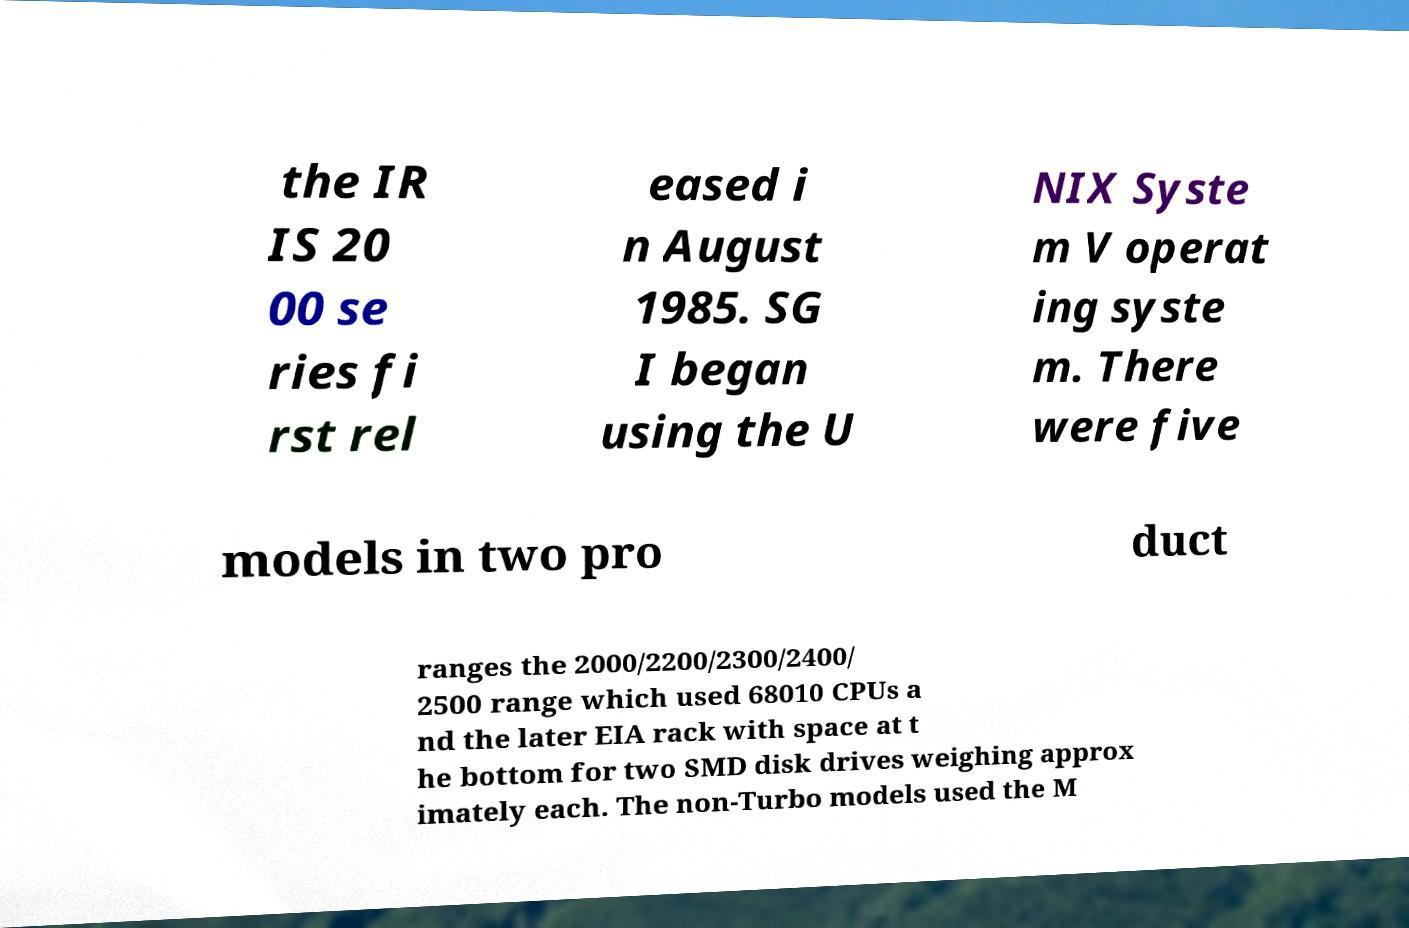I need the written content from this picture converted into text. Can you do that? the IR IS 20 00 se ries fi rst rel eased i n August 1985. SG I began using the U NIX Syste m V operat ing syste m. There were five models in two pro duct ranges the 2000/2200/2300/2400/ 2500 range which used 68010 CPUs a nd the later EIA rack with space at t he bottom for two SMD disk drives weighing approx imately each. The non-Turbo models used the M 